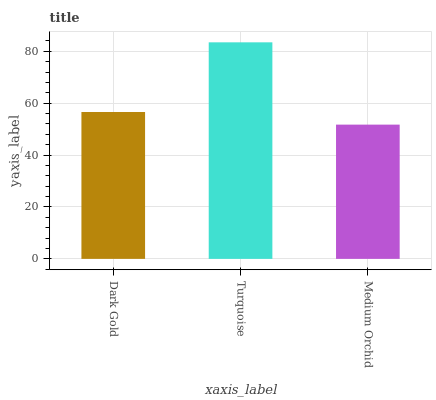Is Medium Orchid the minimum?
Answer yes or no. Yes. Is Turquoise the maximum?
Answer yes or no. Yes. Is Turquoise the minimum?
Answer yes or no. No. Is Medium Orchid the maximum?
Answer yes or no. No. Is Turquoise greater than Medium Orchid?
Answer yes or no. Yes. Is Medium Orchid less than Turquoise?
Answer yes or no. Yes. Is Medium Orchid greater than Turquoise?
Answer yes or no. No. Is Turquoise less than Medium Orchid?
Answer yes or no. No. Is Dark Gold the high median?
Answer yes or no. Yes. Is Dark Gold the low median?
Answer yes or no. Yes. Is Turquoise the high median?
Answer yes or no. No. Is Medium Orchid the low median?
Answer yes or no. No. 